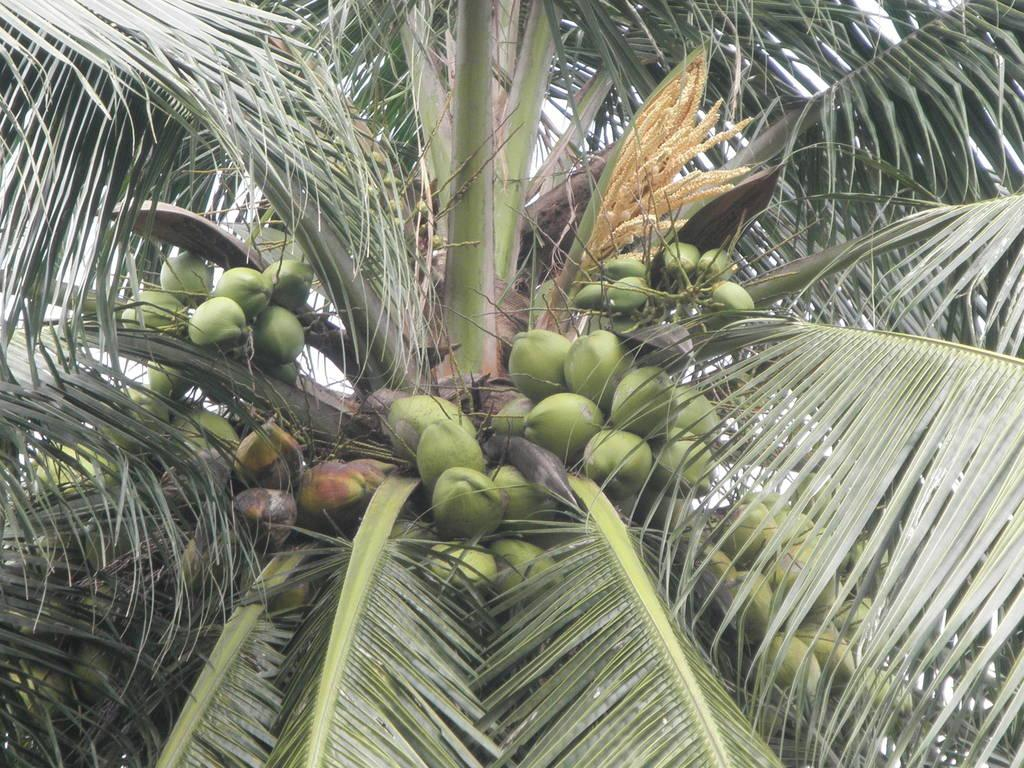What type of tree is visible in the image? There is a coconut tree in the image. What can be found on the coconut tree? There are coconuts on the coconut tree in the image. What type of cannon is present on the coconut tree in the image? There is no cannon present on the coconut tree in the image. What type of pest can be seen on the coconuts in the image? There are no pests visible on the coconuts in the image. 